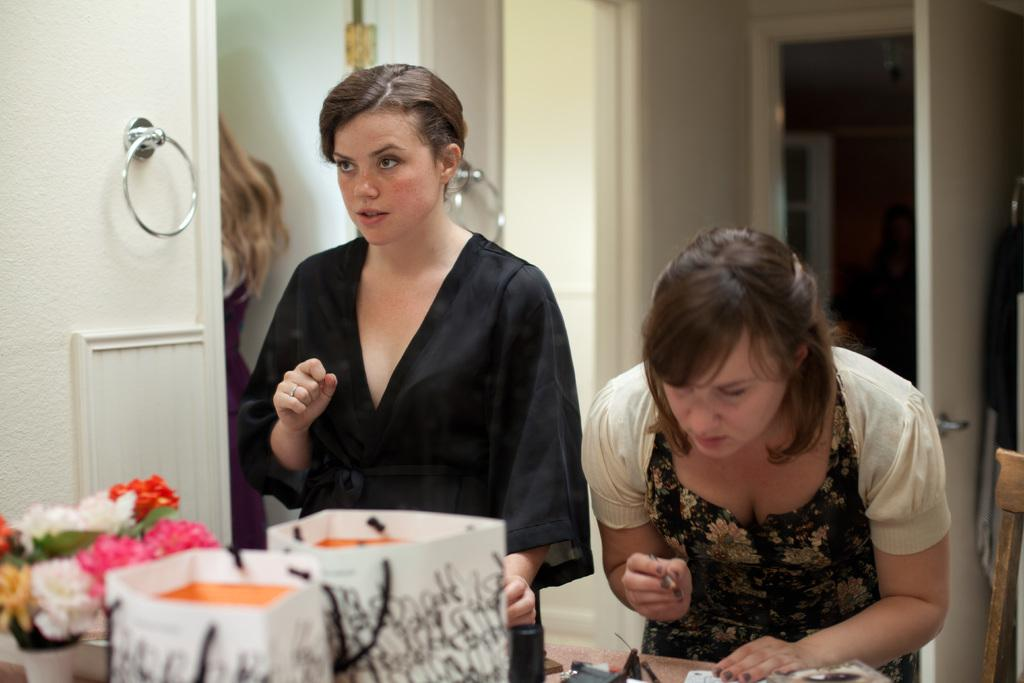What can be seen in the background of the image? There is a door and a wall in the background of the image. What are the two women doing in the image? The two women are standing in front of a table. What items are on the table in the image? There are carry bags and flower pots on the table. What type of pizzas are being served on the table in the image? There are no pizzas present in the image; the table has carry bags and flower pots. What arithmetic problem is being solved by the women in the image? There is no indication of any arithmetic problem being solved in the image; the women are simply standing in front of a table. 